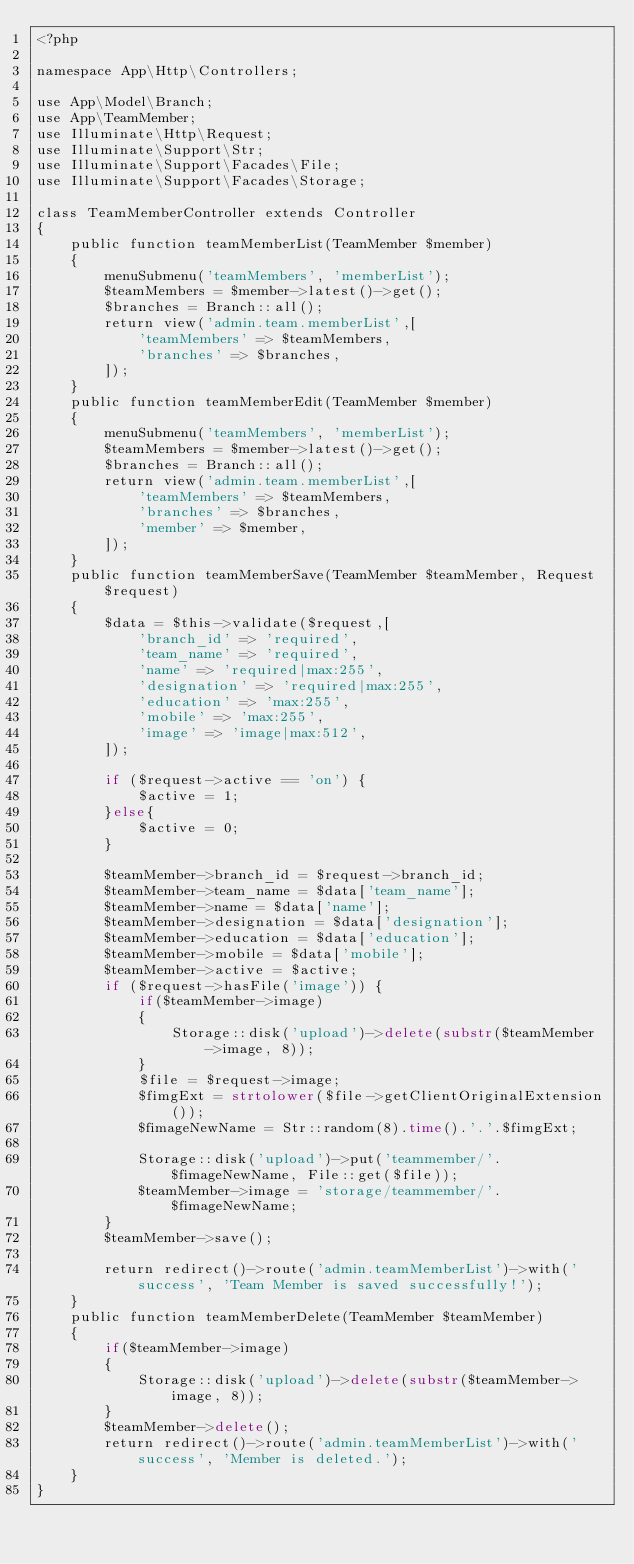Convert code to text. <code><loc_0><loc_0><loc_500><loc_500><_PHP_><?php

namespace App\Http\Controllers;

use App\Model\Branch;
use App\TeamMember;
use Illuminate\Http\Request;
use Illuminate\Support\Str;
use Illuminate\Support\Facades\File;
use Illuminate\Support\Facades\Storage;

class TeamMemberController extends Controller
{
    public function teamMemberList(TeamMember $member)
    {
        menuSubmenu('teamMembers', 'memberList');
        $teamMembers = $member->latest()->get();
        $branches = Branch::all();
        return view('admin.team.memberList',[
            'teamMembers' => $teamMembers,
            'branches' => $branches,
        ]);
    }
    public function teamMemberEdit(TeamMember $member)
    {
        menuSubmenu('teamMembers', 'memberList');
        $teamMembers = $member->latest()->get();
        $branches = Branch::all();
        return view('admin.team.memberList',[
            'teamMembers' => $teamMembers,
            'branches' => $branches,
            'member' => $member,
        ]);
    }
    public function teamMemberSave(TeamMember $teamMember, Request $request)
    {
        $data = $this->validate($request,[
            'branch_id' => 'required',
            'team_name' => 'required',
            'name' => 'required|max:255',
            'designation' => 'required|max:255',
            'education' => 'max:255',
            'mobile' => 'max:255',
            'image' => 'image|max:512',
        ]);

        if ($request->active == 'on') {
            $active = 1;
        }else{
            $active = 0;
        }

        $teamMember->branch_id = $request->branch_id;
        $teamMember->team_name = $data['team_name'];
        $teamMember->name = $data['name'];
        $teamMember->designation = $data['designation'];
        $teamMember->education = $data['education'];
        $teamMember->mobile = $data['mobile'];
        $teamMember->active = $active;
        if ($request->hasFile('image')) {
            if($teamMember->image)
            {
                Storage::disk('upload')->delete(substr($teamMember->image, 8));
            }
            $file = $request->image;
            $fimgExt = strtolower($file->getClientOriginalExtension());               
            $fimageNewName = Str::random(8).time().'.'.$fimgExt;

            Storage::disk('upload')->put('teammember/'.$fimageNewName, File::get($file));
            $teamMember->image = 'storage/teammember/'.$fimageNewName;
        }
        $teamMember->save();

        return redirect()->route('admin.teamMemberList')->with('success', 'Team Member is saved successfully!');
    }
    public function teamMemberDelete(TeamMember $teamMember)
    {
        if($teamMember->image)
        {
            Storage::disk('upload')->delete(substr($teamMember->image, 8));
        }
        $teamMember->delete();
        return redirect()->route('admin.teamMemberList')->with('success', 'Member is deleted.');
    }
}
</code> 